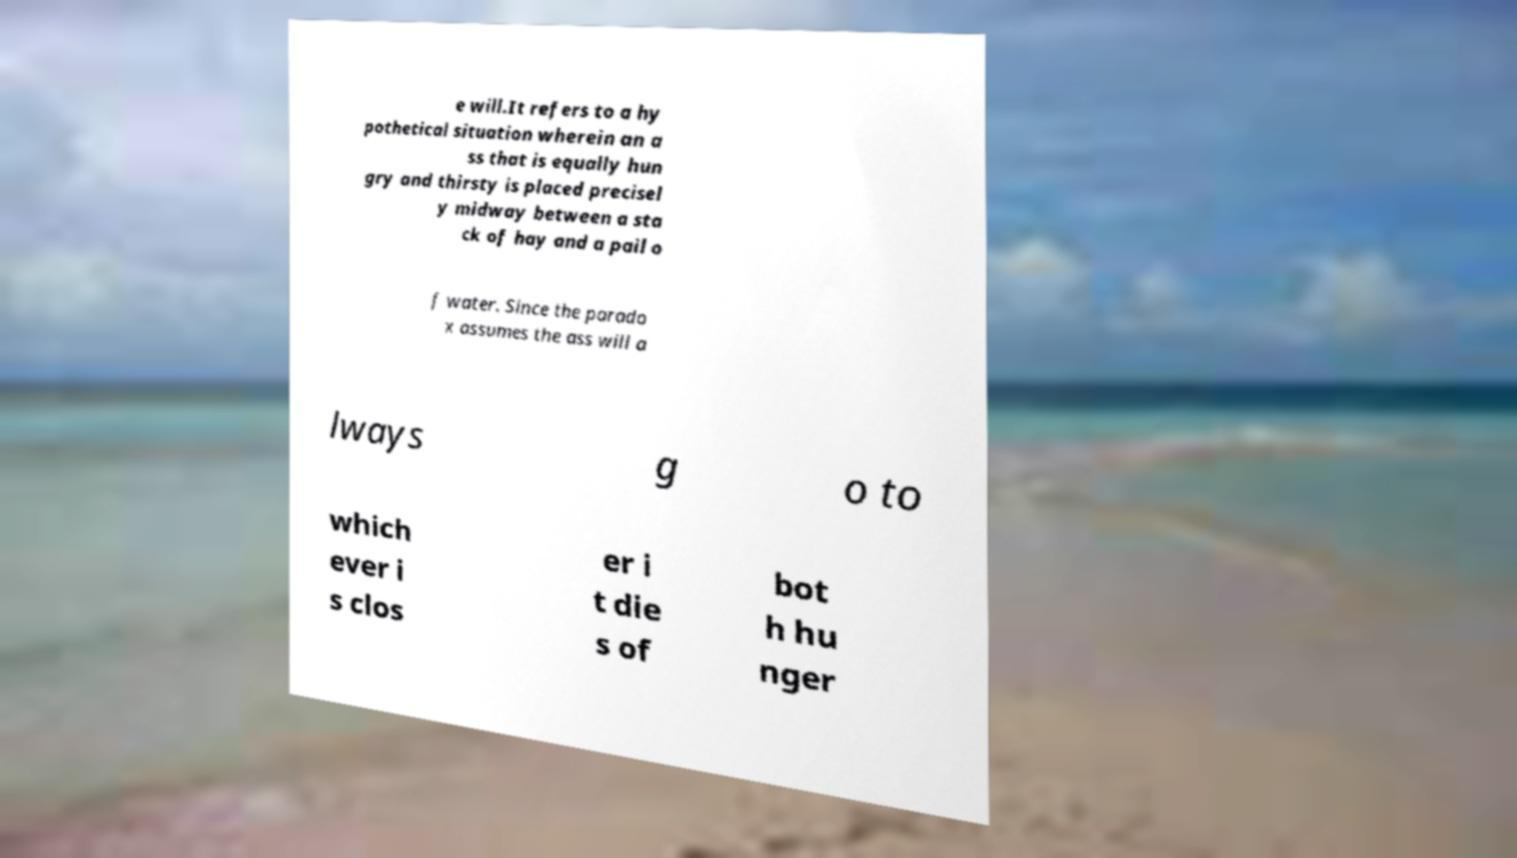There's text embedded in this image that I need extracted. Can you transcribe it verbatim? e will.It refers to a hy pothetical situation wherein an a ss that is equally hun gry and thirsty is placed precisel y midway between a sta ck of hay and a pail o f water. Since the parado x assumes the ass will a lways g o to which ever i s clos er i t die s of bot h hu nger 